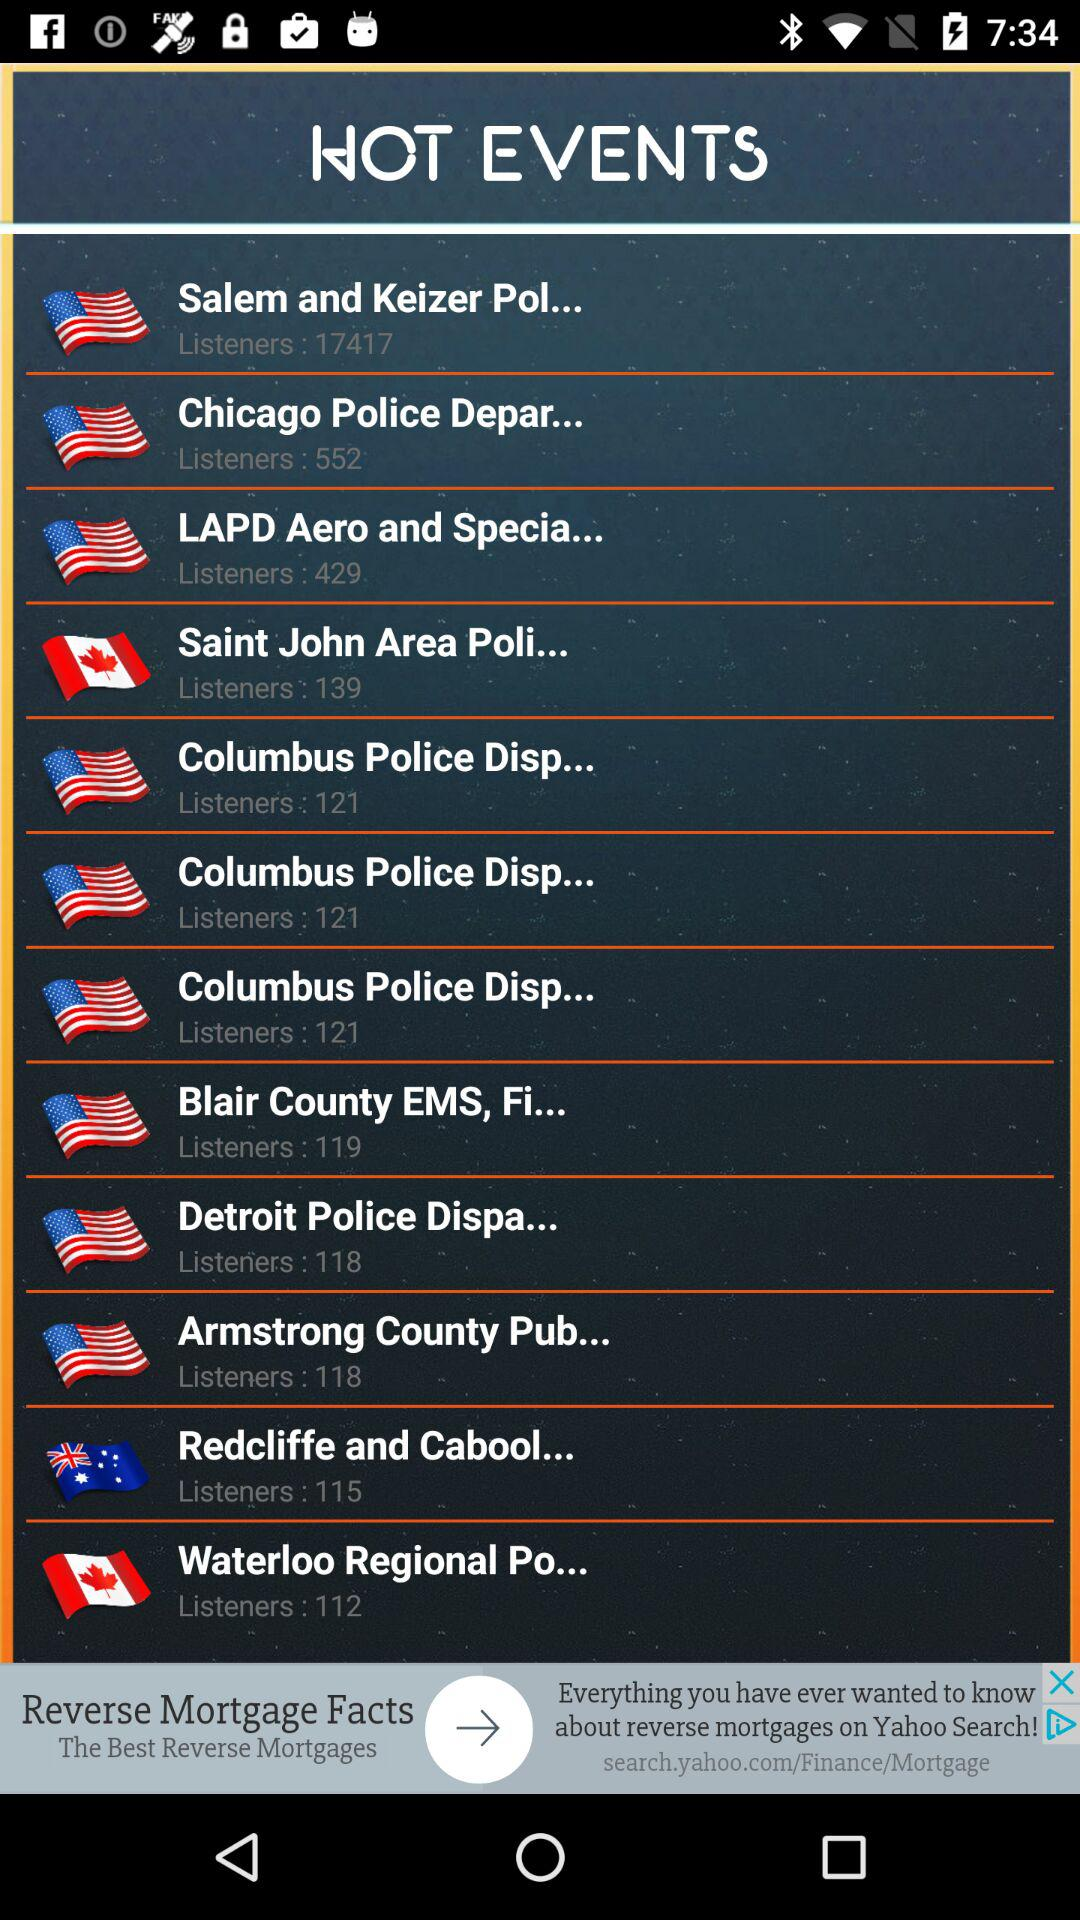Which events have 112 listeners? The event "Waterloo Regional Po..." have 112 listeners. 